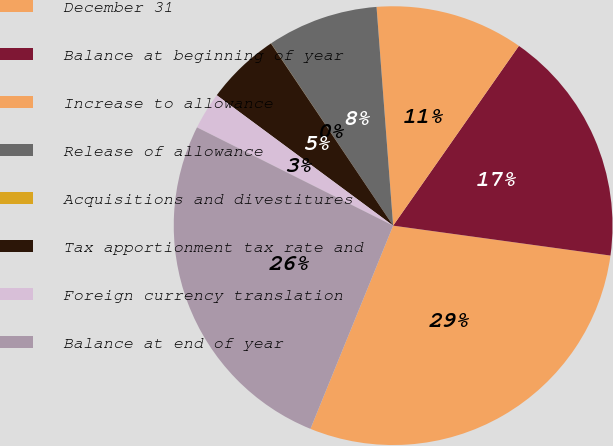Convert chart to OTSL. <chart><loc_0><loc_0><loc_500><loc_500><pie_chart><fcel>December 31<fcel>Balance at beginning of year<fcel>Increase to allowance<fcel>Release of allowance<fcel>Acquisitions and divestitures<fcel>Tax apportionment tax rate and<fcel>Foreign currency translation<fcel>Balance at end of year<nl><fcel>28.97%<fcel>17.46%<fcel>10.92%<fcel>8.19%<fcel>0.01%<fcel>5.46%<fcel>2.74%<fcel>26.24%<nl></chart> 